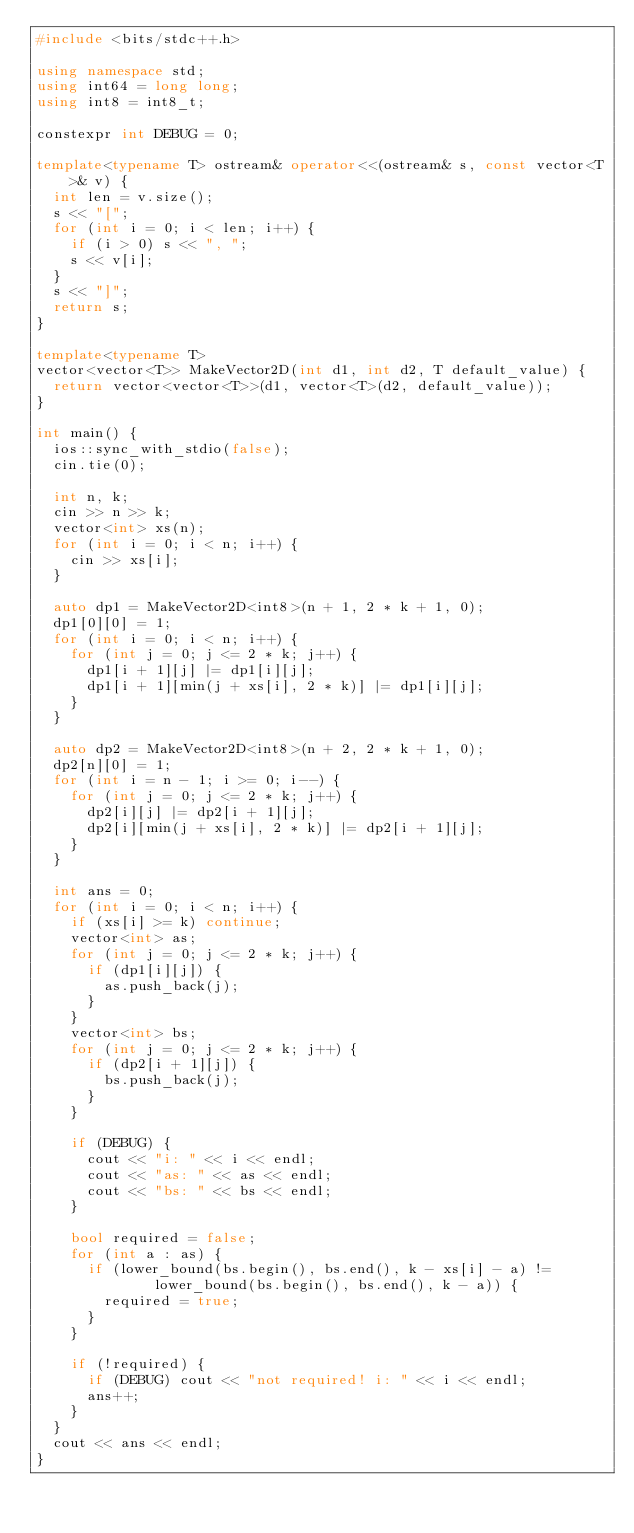<code> <loc_0><loc_0><loc_500><loc_500><_C++_>#include <bits/stdc++.h>

using namespace std;
using int64 = long long;
using int8 = int8_t;

constexpr int DEBUG = 0;

template<typename T> ostream& operator<<(ostream& s, const vector<T>& v) {
  int len = v.size();
  s << "[";
  for (int i = 0; i < len; i++) {
    if (i > 0) s << ", ";
    s << v[i];
  }
  s << "]";
  return s;
}

template<typename T>
vector<vector<T>> MakeVector2D(int d1, int d2, T default_value) {
  return vector<vector<T>>(d1, vector<T>(d2, default_value));
}

int main() {
  ios::sync_with_stdio(false);
  cin.tie(0);

  int n, k;
  cin >> n >> k;
  vector<int> xs(n);
  for (int i = 0; i < n; i++) {
    cin >> xs[i];
  }

  auto dp1 = MakeVector2D<int8>(n + 1, 2 * k + 1, 0);
  dp1[0][0] = 1;
  for (int i = 0; i < n; i++) {
    for (int j = 0; j <= 2 * k; j++) {
      dp1[i + 1][j] |= dp1[i][j];
      dp1[i + 1][min(j + xs[i], 2 * k)] |= dp1[i][j];
    }
  }

  auto dp2 = MakeVector2D<int8>(n + 2, 2 * k + 1, 0);
  dp2[n][0] = 1;
  for (int i = n - 1; i >= 0; i--) {
    for (int j = 0; j <= 2 * k; j++) {
      dp2[i][j] |= dp2[i + 1][j];
      dp2[i][min(j + xs[i], 2 * k)] |= dp2[i + 1][j];
    }
  }

  int ans = 0;
  for (int i = 0; i < n; i++) {
    if (xs[i] >= k) continue;
    vector<int> as;
    for (int j = 0; j <= 2 * k; j++) {
      if (dp1[i][j]) {
        as.push_back(j);
      }
    }
    vector<int> bs;
    for (int j = 0; j <= 2 * k; j++) {
      if (dp2[i + 1][j]) {
        bs.push_back(j);
      }
    }

    if (DEBUG) {
      cout << "i: " << i << endl;
      cout << "as: " << as << endl;
      cout << "bs: " << bs << endl;
    }

    bool required = false;
    for (int a : as) {
      if (lower_bound(bs.begin(), bs.end(), k - xs[i] - a) !=
              lower_bound(bs.begin(), bs.end(), k - a)) {
        required = true;
      }
    }

    if (!required) {
      if (DEBUG) cout << "not required! i: " << i << endl;
      ans++;
    }
  }
  cout << ans << endl;
}</code> 